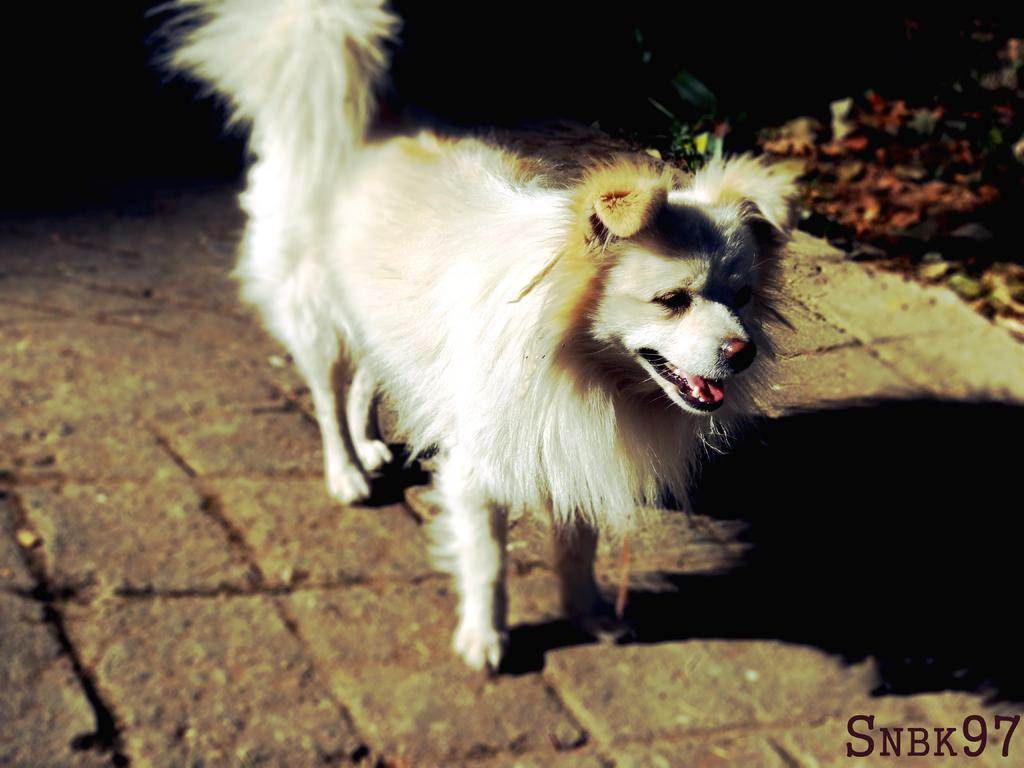What type of animal is in the image? There is a dog in the image. Where is the dog located in the image? The dog is standing on the floor. What can be seen on the ground in the image? There are shredded leaves on the ground in the image. What type of net is being used by the dog in the image? There is no net present in the image; it features a dog standing on the floor with shredded leaves on the ground. 